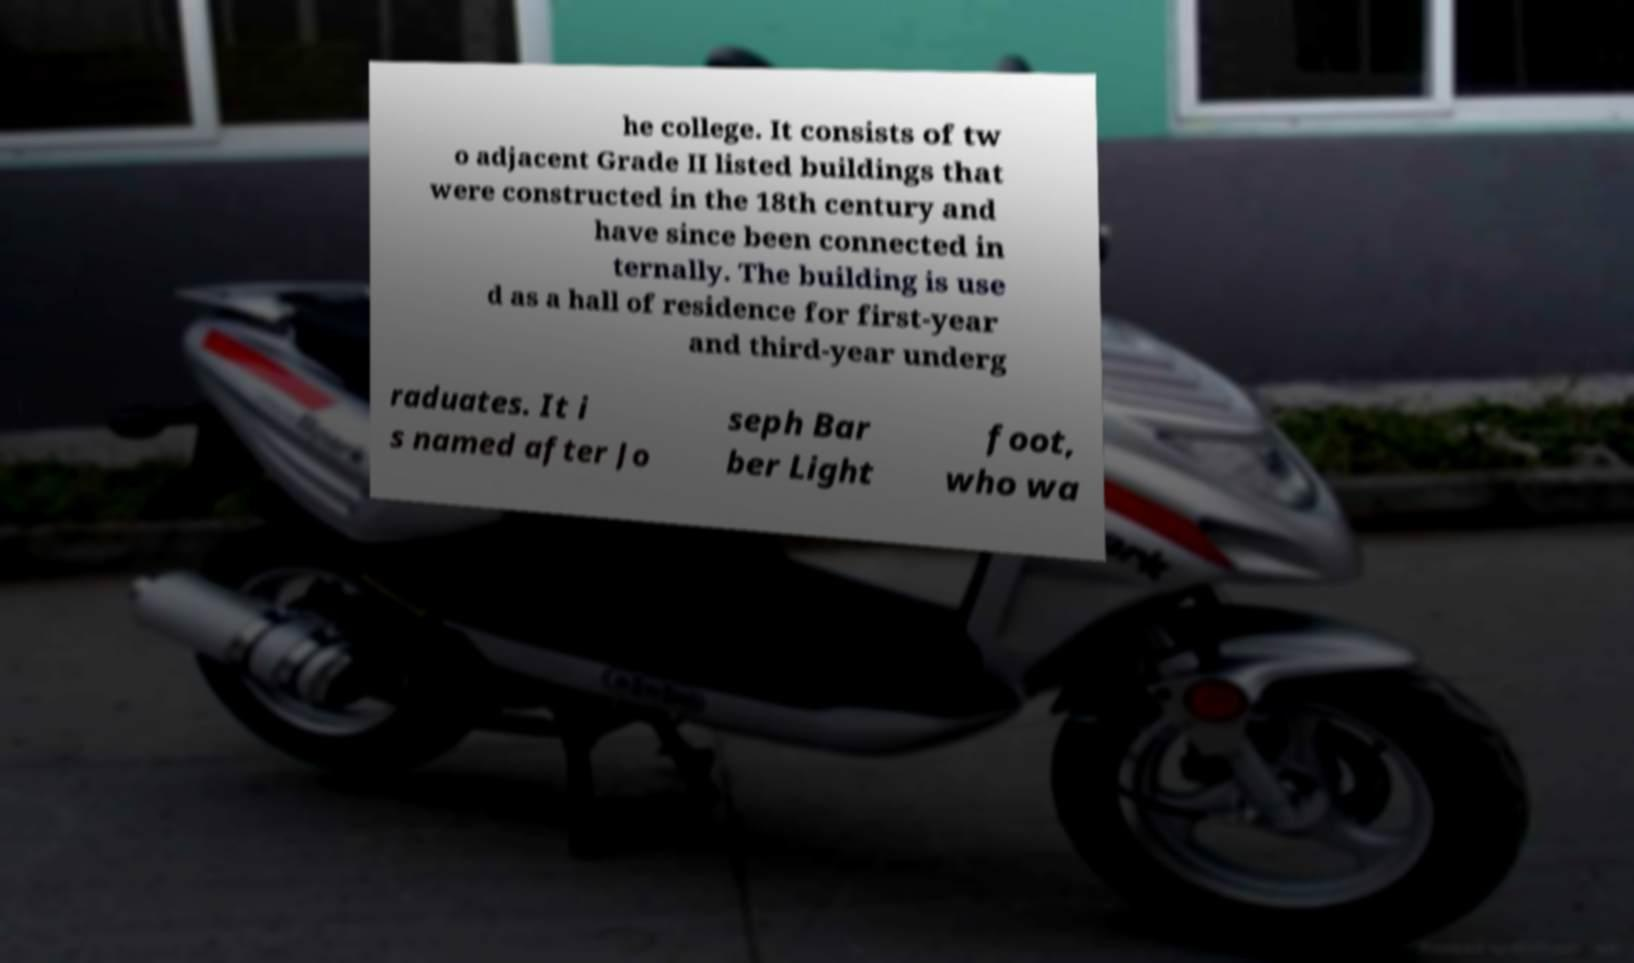There's text embedded in this image that I need extracted. Can you transcribe it verbatim? he college. It consists of tw o adjacent Grade II listed buildings that were constructed in the 18th century and have since been connected in ternally. The building is use d as a hall of residence for first-year and third-year underg raduates. It i s named after Jo seph Bar ber Light foot, who wa 